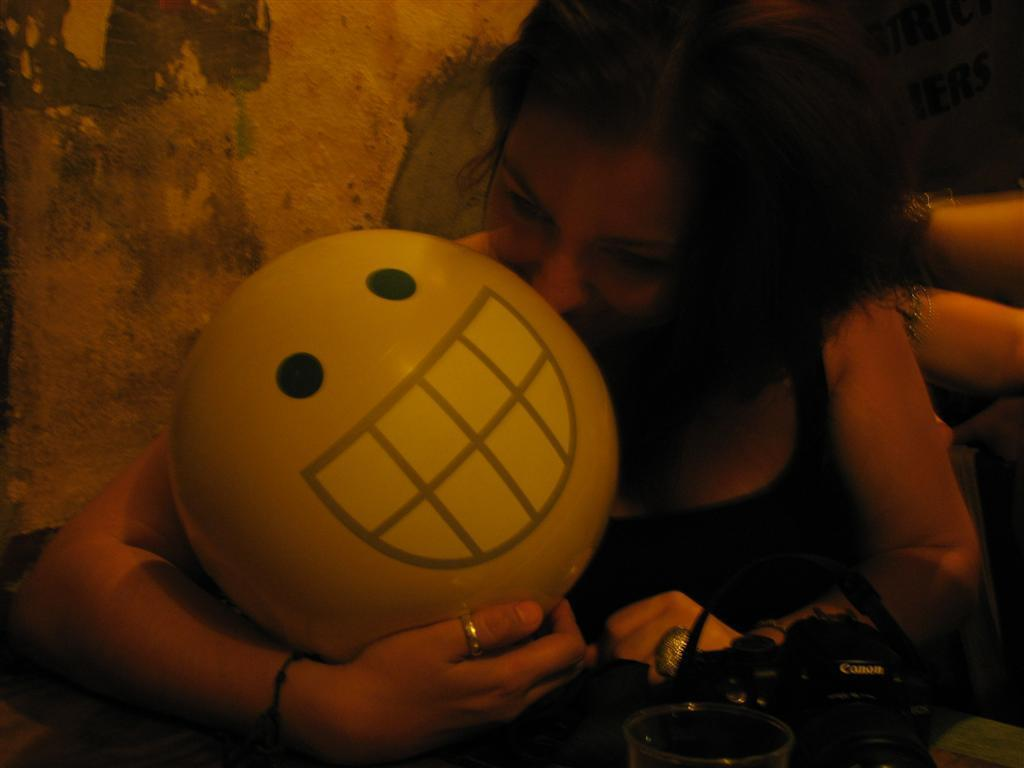Who is the main subject in the image? There is a woman in the image. What is the woman doing in the image? The woman is sitting and kissing a yellow ball. What is the appearance of the ball? The ball has a smile symbol on it. What color is the woman's top in the image? The woman is wearing a black top. Is the woman driving a car in the image? No, the woman is not driving a car in the image; she is sitting and kissing a yellow ball. Can you see a picture of a landscape on the wall behind the woman? There is no mention of a landscape or a wall in the image, so it cannot be determined if there is a picture present. 